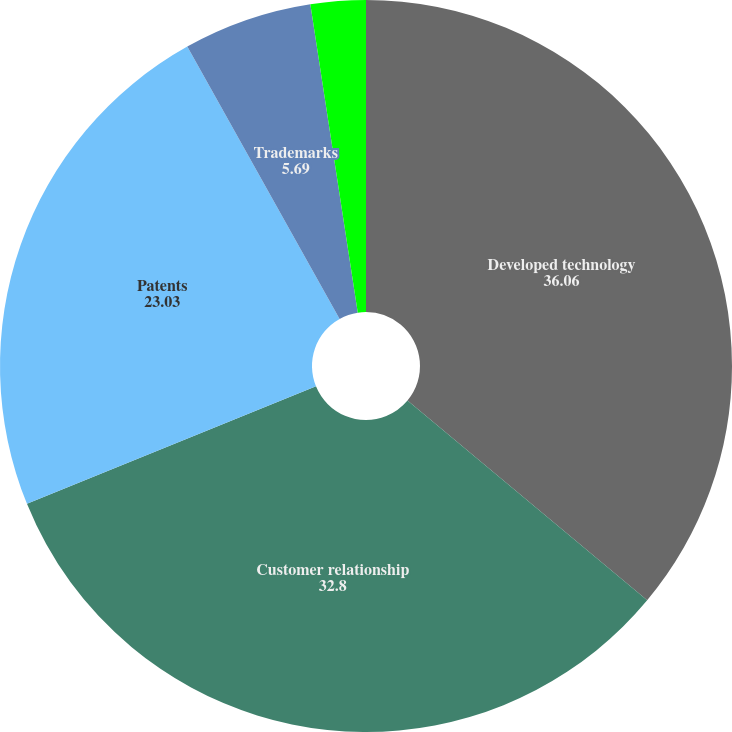Convert chart. <chart><loc_0><loc_0><loc_500><loc_500><pie_chart><fcel>Developed technology<fcel>Customer relationship<fcel>Patents<fcel>Trademarks<fcel>Other<nl><fcel>36.06%<fcel>32.8%<fcel>23.03%<fcel>5.69%<fcel>2.43%<nl></chart> 